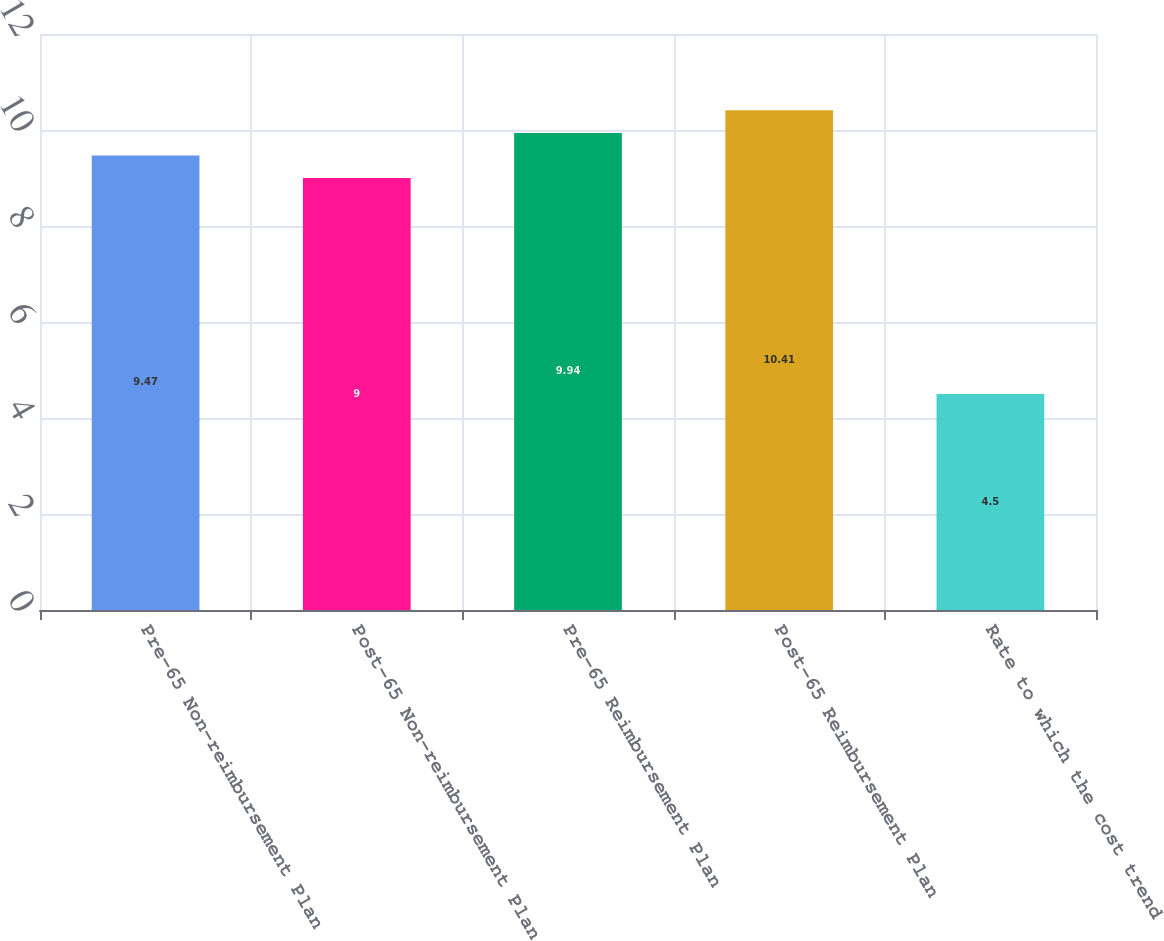Convert chart. <chart><loc_0><loc_0><loc_500><loc_500><bar_chart><fcel>Pre-65 Non-reimbursement Plan<fcel>Post-65 Non-reimbursement Plan<fcel>Pre-65 Reimbursement Plan<fcel>Post-65 Reimbursement Plan<fcel>Rate to which the cost trend<nl><fcel>9.47<fcel>9<fcel>9.94<fcel>10.41<fcel>4.5<nl></chart> 